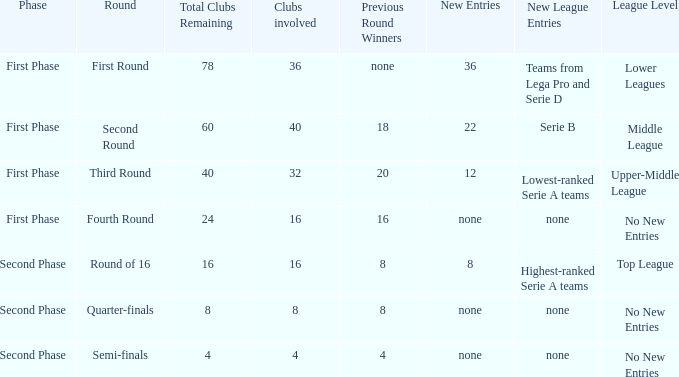Write the full table. {'header': ['Phase', 'Round', 'Total Clubs Remaining', 'Clubs involved', 'Previous Round Winners', 'New Entries', 'New League Entries', 'League Level'], 'rows': [['First Phase', 'First Round', '78', '36', 'none', '36', 'Teams from Lega Pro and Serie D', 'Lower Leagues'], ['First Phase', 'Second Round', '60', '40', '18', '22', 'Serie B', 'Middle League'], ['First Phase', 'Third Round', '40', '32', '20', '12', 'Lowest-ranked Serie A teams', 'Upper-Middle League'], ['First Phase', 'Fourth Round', '24', '16', '16', 'none', 'none', 'No New Entries'], ['Second Phase', 'Round of 16', '16', '16', '8', '8', 'Highest-ranked Serie A teams', 'Top League'], ['Second Phase', 'Quarter-finals', '8', '8', '8', 'none', 'none', 'No New Entries'], ['Second Phase', 'Semi-finals', '4', '4', '4', 'none', 'none', 'No New Entries']]} Considering the circular label of the third stage, what new inclusions might be encountered during this round? 12.0. 